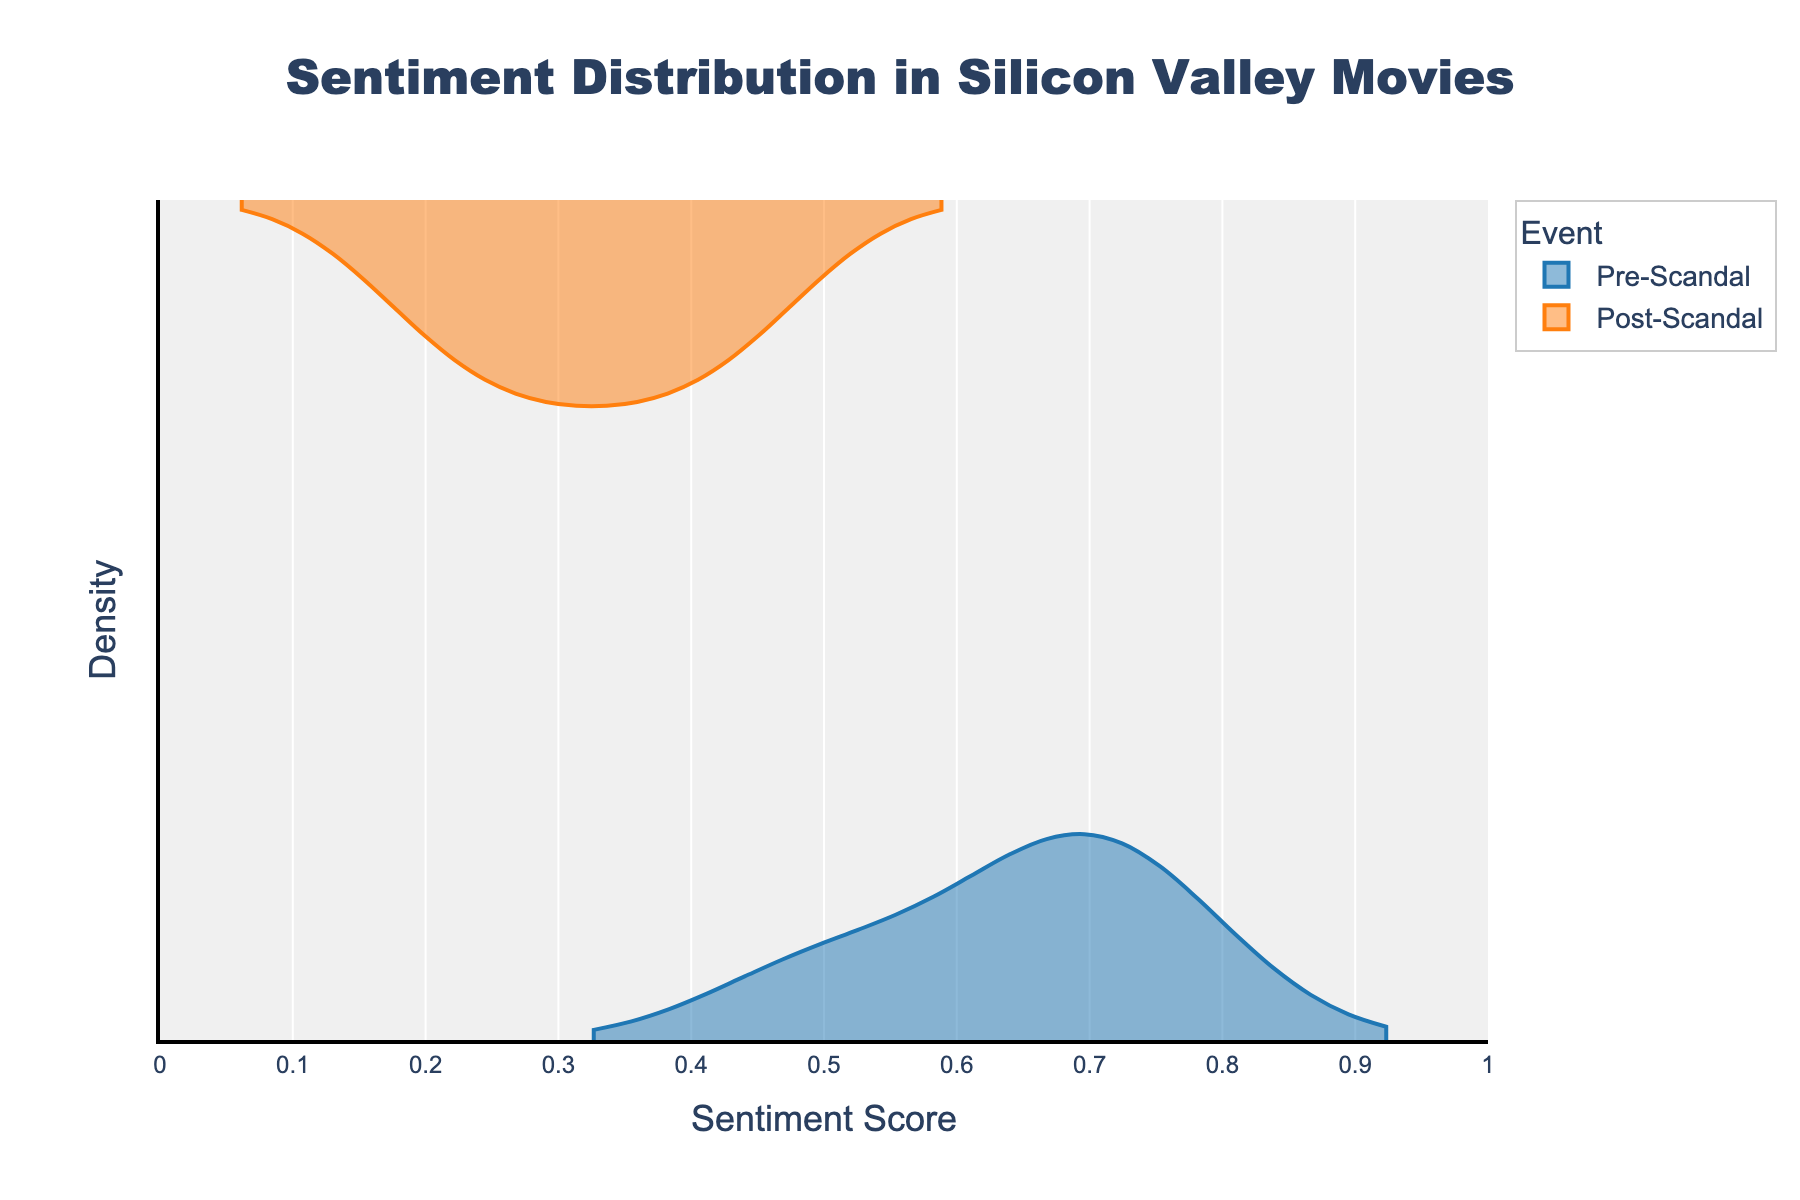what is the title of the plot The title of the plot is displayed at the top. It is centered and reads "Sentiment Distribution in Silicon Valley Movies".
Answer: Sentiment Distribution in Silicon Valley Movies What are the two groups represented in the plot? There are two groups represented in the plot as seen by the legend on the right. The groups are "Pre-Scandal" and "Post-Scandal".
Answer: Pre-Scandal, Post-Scandal Which group has a higher overall sentiment score according to the density plot? By looking at the density plot, the "Pre-Scandal" group has violin traces more skewed towards higher sentiment scores compared to the "Post-Scandal" group.
Answer: Pre-Scandal What is the peak sentiment score for the "Post-Scandal" group according to the density plot? From the ".." color representation, the highest density point for the "Post-Scandal" group is around the sentiment score of 0.35.
Answer: 0.35 Which sentiment score range shows an overlap in density between Pre-Scandal and Post-Scandal movies? Examining where the densities of the two groups overlap, both groups have densities in the sentiment score range of roughly 0.25 to 0.45.
Answer: 0.25 - 0.45 What is the approximate range of sentiment scores for the "Pre-Scandal" group? From looking at the extent of the violin plot for the "Pre-Scandal" group, it spans roughly from 0.50 to 0.75.
Answer: 0.50 - 0.75 How do the densities of the "Pre-Scandal" and "Post-Scandal" groups compare at a sentiment score of 0.65? At a sentiment score of 0.65, the "Pre-Scandal" group shows a significant density, whereas the "Post-Scandal" group shows almost no density.
Answer: Pre-Scandal has higher density Do the plots indicate any movements toward negative sentiment scores post-scandal? Yes, the "Post-Scandal" group shows much higher densities in the lower sentiment score ranges, indicating a shift towards more negative sentiment.
Answer: Yes What is the interquartile range (IQR) for the "Pre-Scandal" sentiment scores? The approximate IQR can be estimated by looking at the spread of the main bulk of the "Pre-Scandal" density plot, which lies between approximately 0.65 and 0.75.
Answer: 0.65 - 0.75 